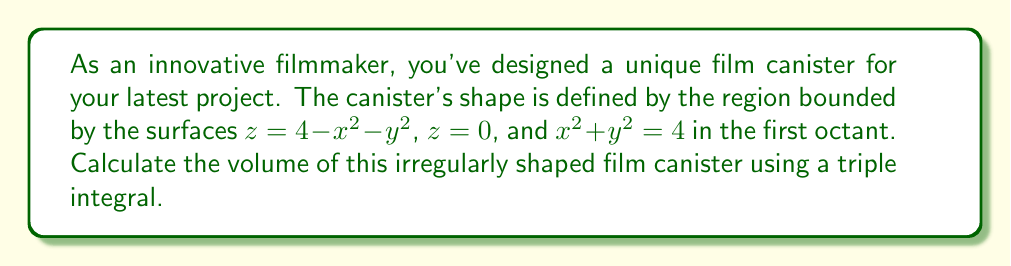Can you answer this question? To solve this problem, we'll use cylindrical coordinates and set up a triple integral. Let's approach this step-by-step:

1) First, let's visualize the region. The bottom surface is the xy-plane (z = 0), the top surface is a paraboloid (z = 4 - x^2 - y^2), and it's bounded by a cylinder (x^2 + y^2 = 4) in the first octant.

2) In cylindrical coordinates:
   $x = r \cos(\theta)$
   $y = r \sin(\theta)$
   $z = z$

3) The bounds for our integral will be:
   $0 \leq \theta \leq \frac{\pi}{2}$ (first quadrant in xy-plane)
   $0 \leq r \leq 2$ (radius of bounding cylinder)
   $0 \leq z \leq 4 - r^2$ (from z = 0 to the paraboloid surface)

4) The volume element in cylindrical coordinates is $r \, dr \, d\theta \, dz$

5) Setting up the triple integral:

   $$V = \int_0^{\frac{\pi}{2}} \int_0^2 \int_0^{4-r^2} r \, dz \, dr \, d\theta$$

6) Integrating with respect to z:

   $$V = \int_0^{\frac{\pi}{2}} \int_0^2 r(4-r^2) \, dr \, d\theta$$

7) Integrating with respect to r:

   $$V = \int_0^{\frac{\pi}{2}} \left[2r^2 - \frac{r^4}{4}\right]_0^2 \, d\theta$$
   $$= \int_0^{\frac{\pi}{2}} \left(8 - 4\right) \, d\theta = \int_0^{\frac{\pi}{2}} 4 \, d\theta$$

8) Finally, integrating with respect to θ:

   $$V = 4 \cdot \frac{\pi}{2} = 2\pi$$

Therefore, the volume of the film canister is $2\pi$ cubic units.
Answer: $2\pi$ cubic units 